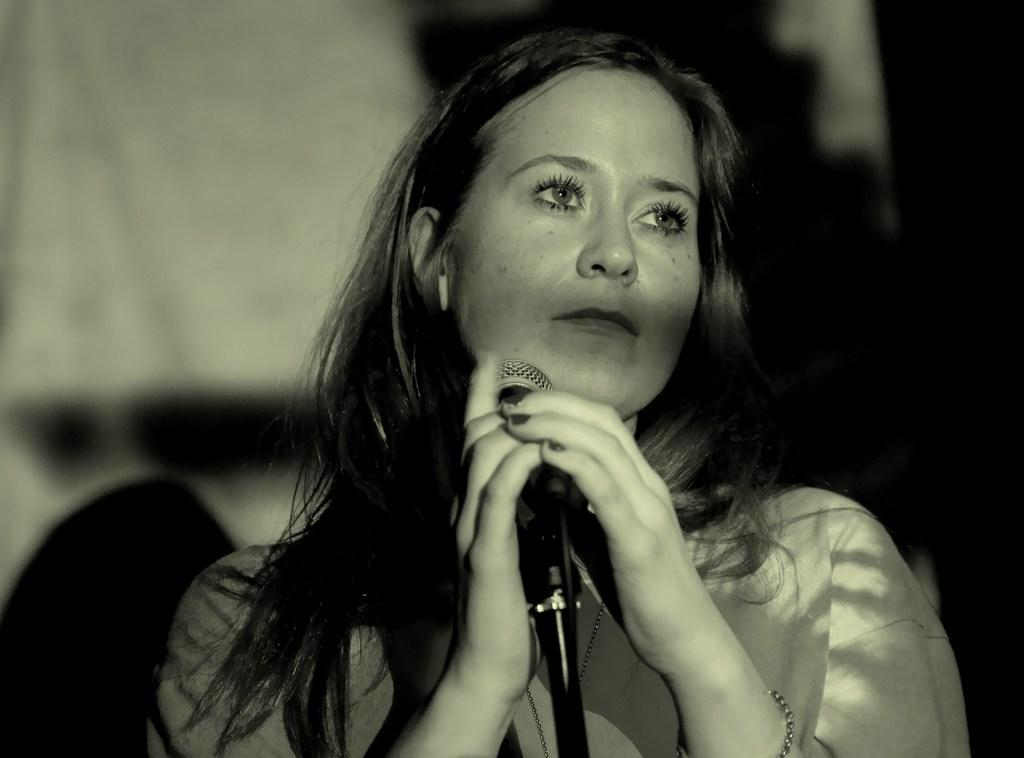Who is the main subject in the image? There is a woman in the image. What is the woman doing in the image? The woman is speaking in the image. How is the woman amplifying her voice in the image? The woman is using a microphone to speak in the image. What type of fruit is the woman holding in the image? There is no fruit present in the image; the woman is using a microphone to speak. 